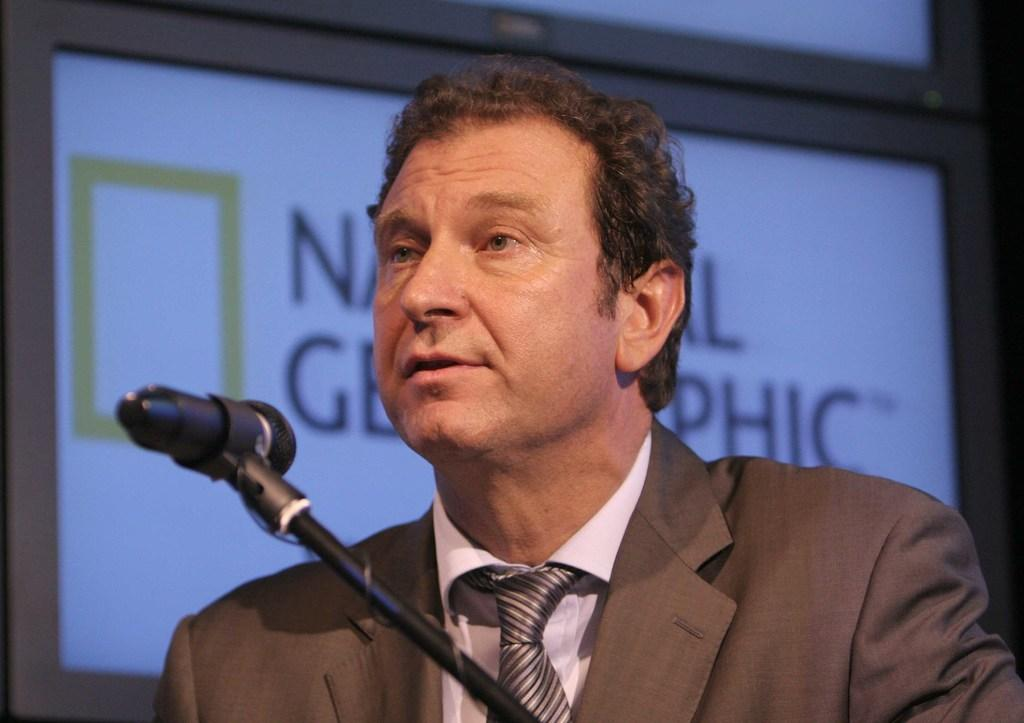Who or what is in the image? There is a person in the image. What is the person doing or interacting with? The person is in front of a microphone. What else can be seen in the image? There is a projector screen in the image. What type of magic does the person perform with the microphone in the image? There is no indication of magic or any magical activity in the image; the person is simply in front of a microphone. 